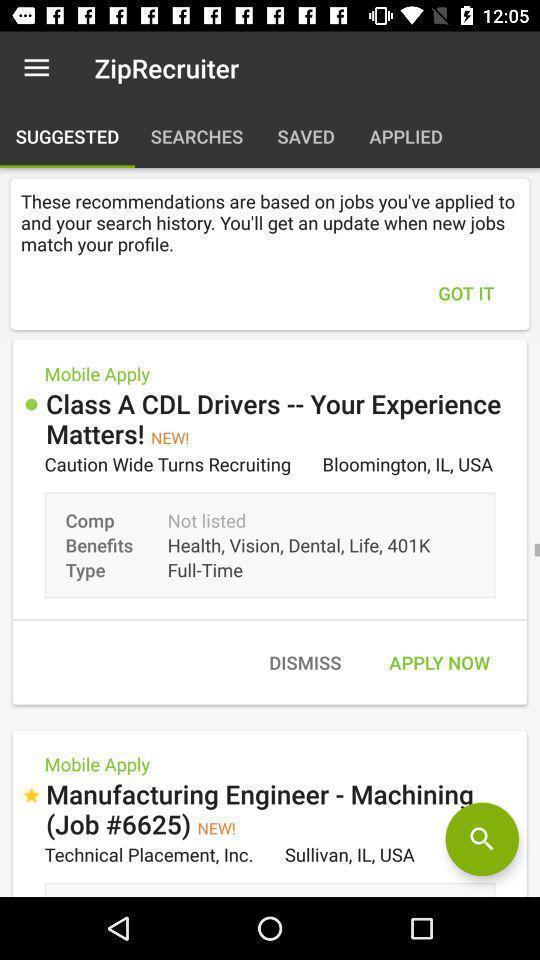Describe this image in words. Page for the job application with search logo. 